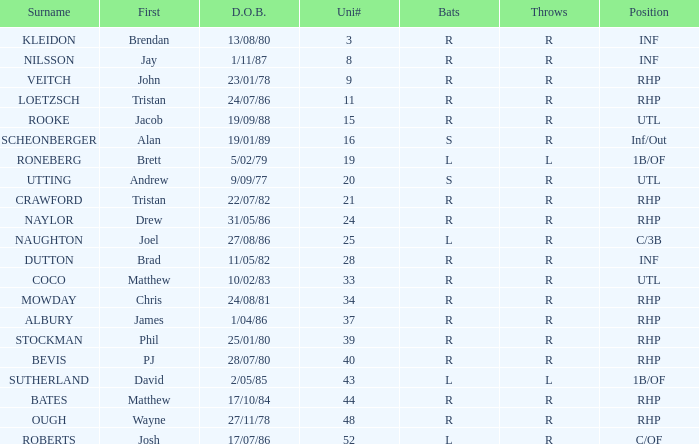Which Position has a Surname of naylor? RHP. 